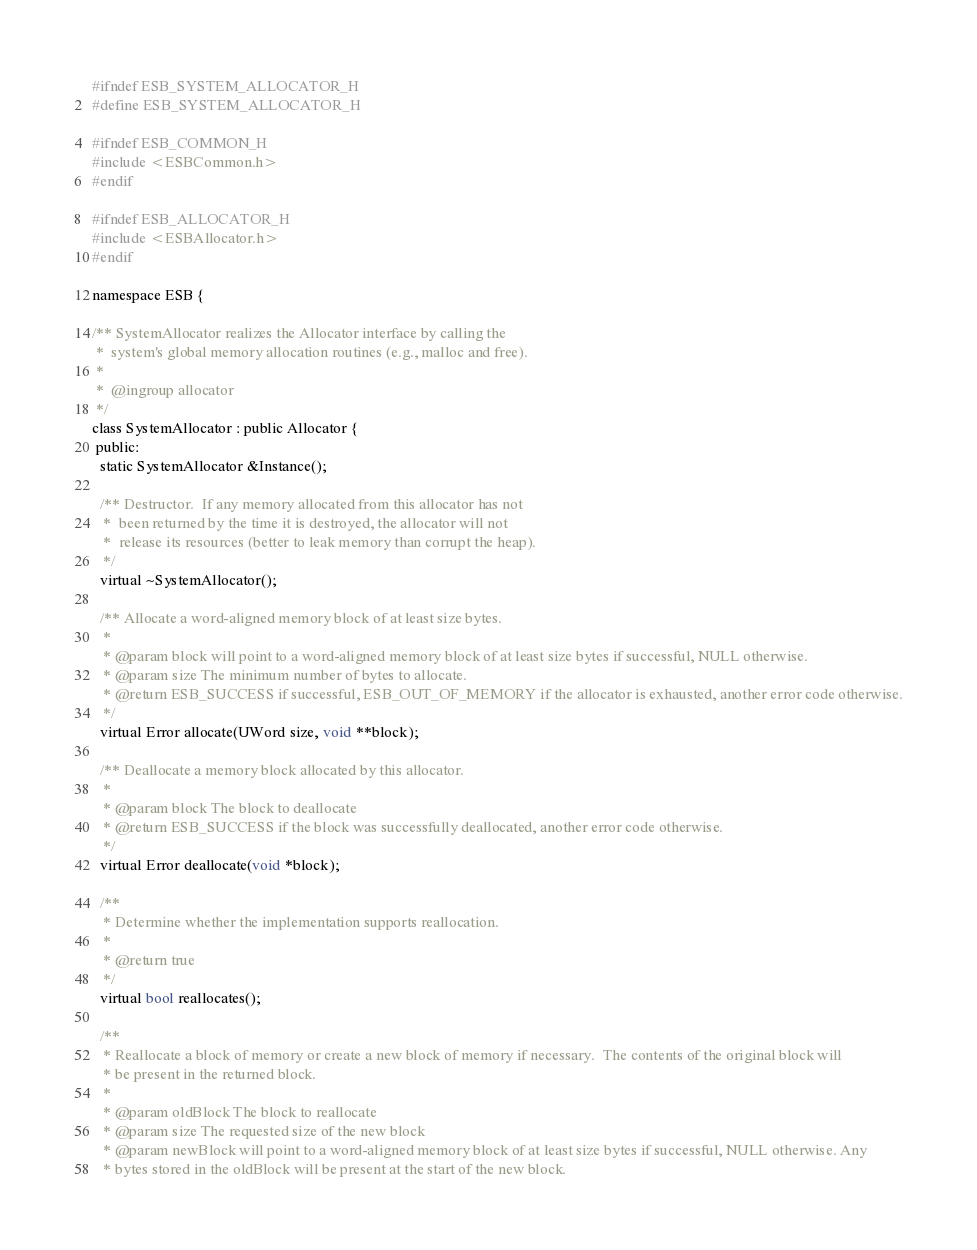<code> <loc_0><loc_0><loc_500><loc_500><_C_>#ifndef ESB_SYSTEM_ALLOCATOR_H
#define ESB_SYSTEM_ALLOCATOR_H

#ifndef ESB_COMMON_H
#include <ESBCommon.h>
#endif

#ifndef ESB_ALLOCATOR_H
#include <ESBAllocator.h>
#endif

namespace ESB {

/** SystemAllocator realizes the Allocator interface by calling the
 *  system's global memory allocation routines (e.g., malloc and free).
 *
 *  @ingroup allocator
 */
class SystemAllocator : public Allocator {
 public:
  static SystemAllocator &Instance();

  /** Destructor.  If any memory allocated from this allocator has not
   *  been returned by the time it is destroyed, the allocator will not
   *  release its resources (better to leak memory than corrupt the heap).
   */
  virtual ~SystemAllocator();

  /** Allocate a word-aligned memory block of at least size bytes.
   *
   * @param block will point to a word-aligned memory block of at least size bytes if successful, NULL otherwise.
   * @param size The minimum number of bytes to allocate.
   * @return ESB_SUCCESS if successful, ESB_OUT_OF_MEMORY if the allocator is exhausted, another error code otherwise.
   */
  virtual Error allocate(UWord size, void **block);

  /** Deallocate a memory block allocated by this allocator.
   *
   * @param block The block to deallocate
   * @return ESB_SUCCESS if the block was successfully deallocated, another error code otherwise.
   */
  virtual Error deallocate(void *block);

  /**
   * Determine whether the implementation supports reallocation.
   *
   * @return true
   */
  virtual bool reallocates();

  /**
   * Reallocate a block of memory or create a new block of memory if necessary.  The contents of the original block will
   * be present in the returned block.
   *
   * @param oldBlock The block to reallocate
   * @param size The requested size of the new block
   * @param newBlock will point to a word-aligned memory block of at least size bytes if successful, NULL otherwise. Any
   * bytes stored in the oldBlock will be present at the start of the new block.</code> 